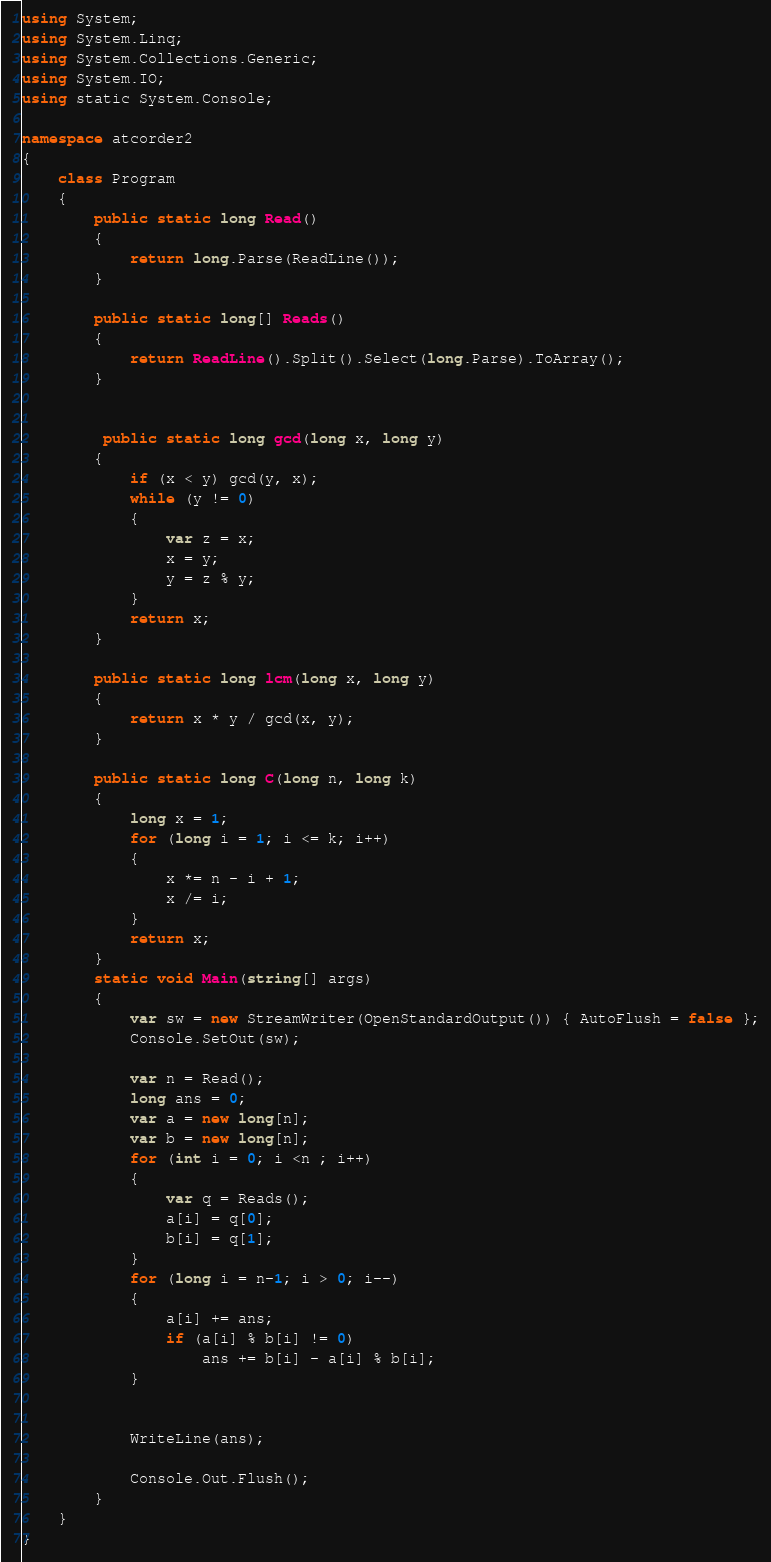<code> <loc_0><loc_0><loc_500><loc_500><_C#_>using System;
using System.Linq;
using System.Collections.Generic;
using System.IO;
using static System.Console;

namespace atcorder2
{
    class Program
    {
        public static long Read()
        {
            return long.Parse(ReadLine());
        }

        public static long[] Reads()
        {
            return ReadLine().Split().Select(long.Parse).ToArray();
        }

        
         public static long gcd(long x, long y)
        {
            if (x < y) gcd(y, x);
            while (y != 0)
            {
                var z = x;
                x = y;
                y = z % y;
            }
            return x;
        }

        public static long lcm(long x, long y)
        {
            return x * y / gcd(x, y);
        } 

        public static long C(long n, long k)
        {
            long x = 1;
            for (long i = 1; i <= k; i++)
            {
                x *= n - i + 1;
                x /= i;
            }
            return x;
        }
        static void Main(string[] args)
        {
            var sw = new StreamWriter(OpenStandardOutput()) { AutoFlush = false };
            Console.SetOut(sw);

            var n = Read();
            long ans = 0;
            var a = new long[n];
            var b = new long[n];
            for (int i = 0; i <n ; i++)
            {
                var q = Reads();
                a[i] = q[0];
                b[i] = q[1];
            }
            for (long i = n-1; i > 0; i--)
            {
                a[i] += ans;
                if (a[i] % b[i] != 0)
                    ans += b[i] - a[i] % b[i];
            }
           
        
            WriteLine(ans);

            Console.Out.Flush();
        }
    }
}
</code> 